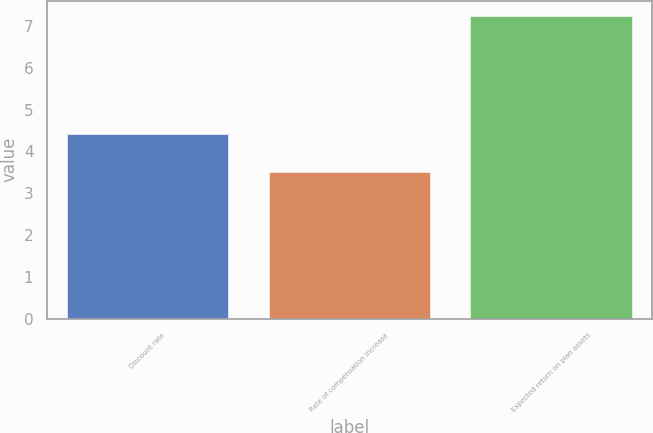Convert chart. <chart><loc_0><loc_0><loc_500><loc_500><bar_chart><fcel>Discount rate<fcel>Rate of compensation increase<fcel>Expected return on plan assets<nl><fcel>4.43<fcel>3.5<fcel>7.25<nl></chart> 